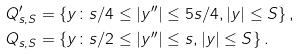Convert formula to latex. <formula><loc_0><loc_0><loc_500><loc_500>Q ^ { \prime } _ { s , S } & = \{ y \colon s / 4 \leq | y ^ { \prime \prime } | \leq 5 s / 4 , | y | \leq S \} \, , \\ Q _ { s , S } & = \{ y \colon s / 2 \leq | y ^ { \prime \prime } | \leq s , | y | \leq S \} \, .</formula> 